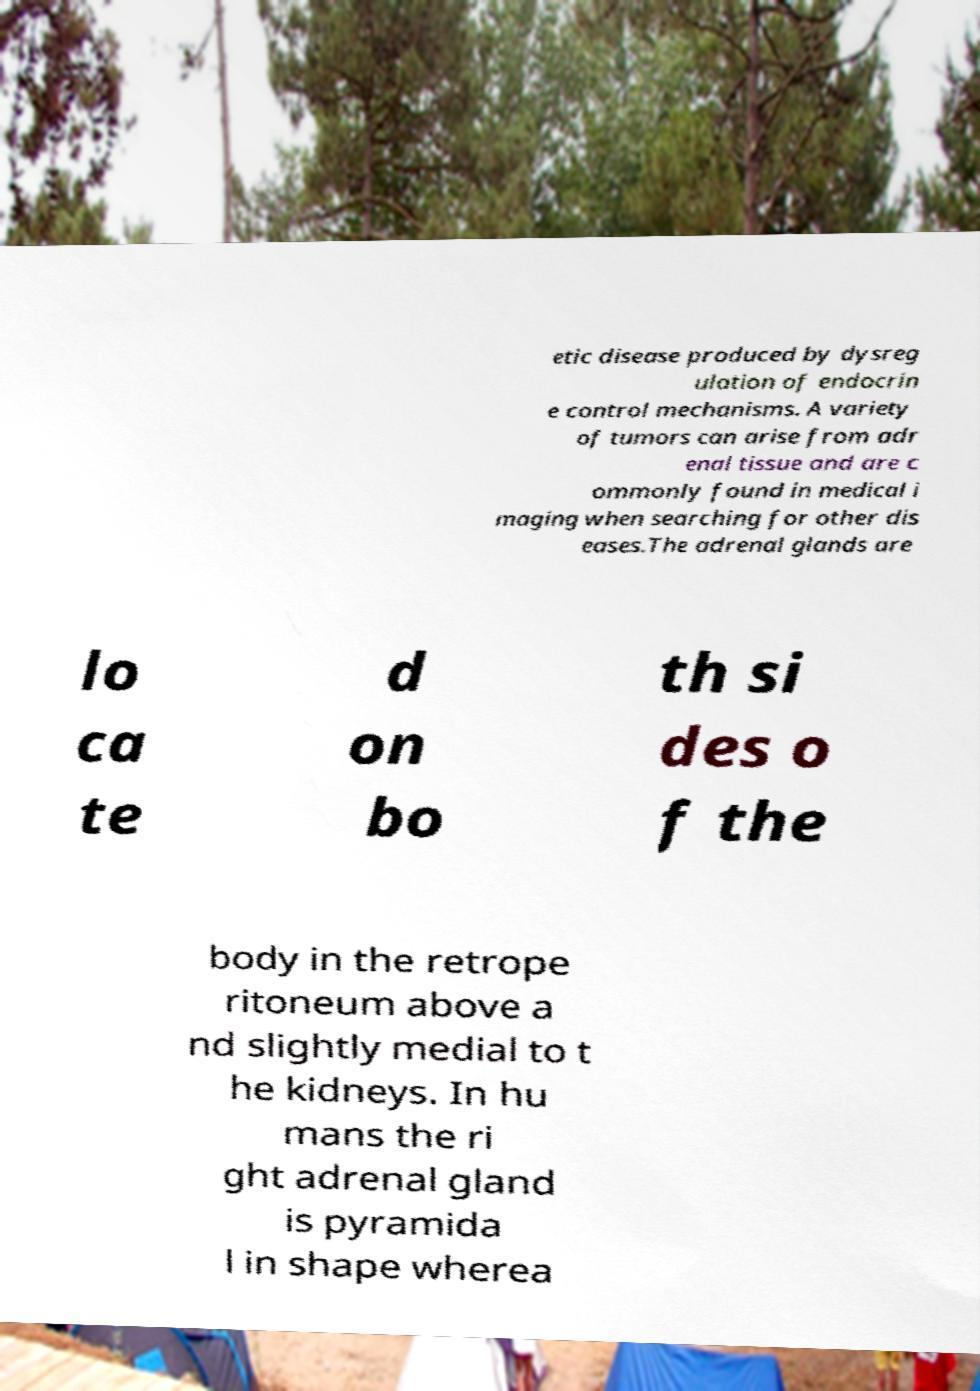Can you accurately transcribe the text from the provided image for me? etic disease produced by dysreg ulation of endocrin e control mechanisms. A variety of tumors can arise from adr enal tissue and are c ommonly found in medical i maging when searching for other dis eases.The adrenal glands are lo ca te d on bo th si des o f the body in the retrope ritoneum above a nd slightly medial to t he kidneys. In hu mans the ri ght adrenal gland is pyramida l in shape wherea 